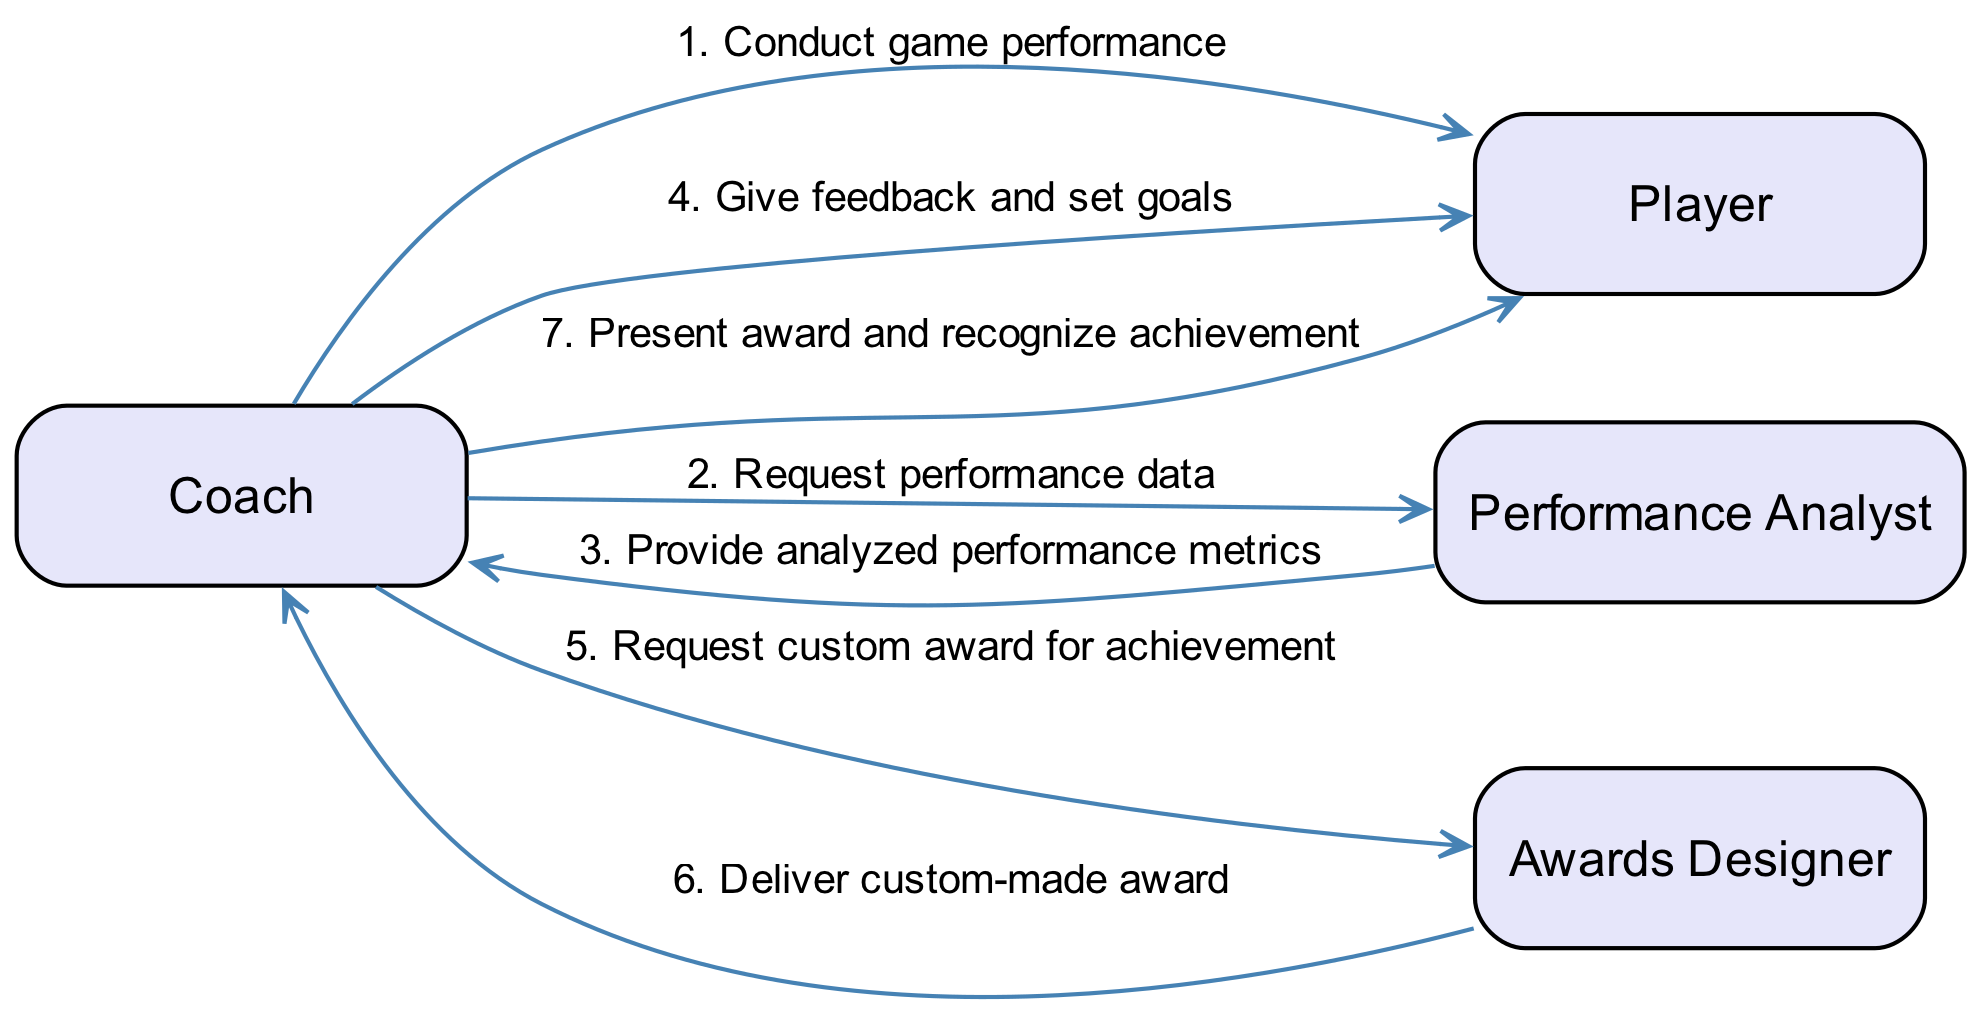What is the first message in the sequence? The first message in the sequence is sent from the Coach to the Player, which is "Conduct game performance." Since the messages are ordered and start from the Coach to the Player, this is the first action.
Answer: Conduct game performance Who receives the feedback from the Coach? The Coach gives feedback to the Player after receiving analyzed performance metrics from the Performance Analyst. Therefore, the Player is the recipient of the feedback.
Answer: Player How many actors are in the diagram? The diagram lists four actors: Coach, Player, Performance Analyst, and Awards Designer. By counting each actor, we confirm the total number.
Answer: Four What is the last action performed in the sequence? The last action in the sequence is when the Coach presents an award to the Player to recognize their achievement. The flow indicates that this is the final step taken after all prior interactions.
Answer: Present award and recognize achievement What role follows the Coach after the feedback? After the Coach gives feedback to the Player, the next action is for the Coach to request a custom award from the Awards Designer. The sequence shows that the Awards Designer interacts with the Coach immediately after.
Answer: Awards Designer Which actor provides analyzed performance metrics to the Coach? The Performance Analyst is responsible for delivering the analyzed performance metrics to the Coach. The sequence directly shows this exchange.
Answer: Performance Analyst How many messages are exchanged between the Coach and the Player? There are three messages exchanged specifically between the Coach and the Player: conducting game performance, giving feedback and setting goals, and presenting the award. Counting these interactions provides the total.
Answer: Three What is the message from the Awards Designer to the Coach? The Awards Designer sends the message "Deliver custom-made award" to the Coach after the request has been made. This action follows directly after the Coach's request in the sequence.
Answer: Deliver custom-made award 